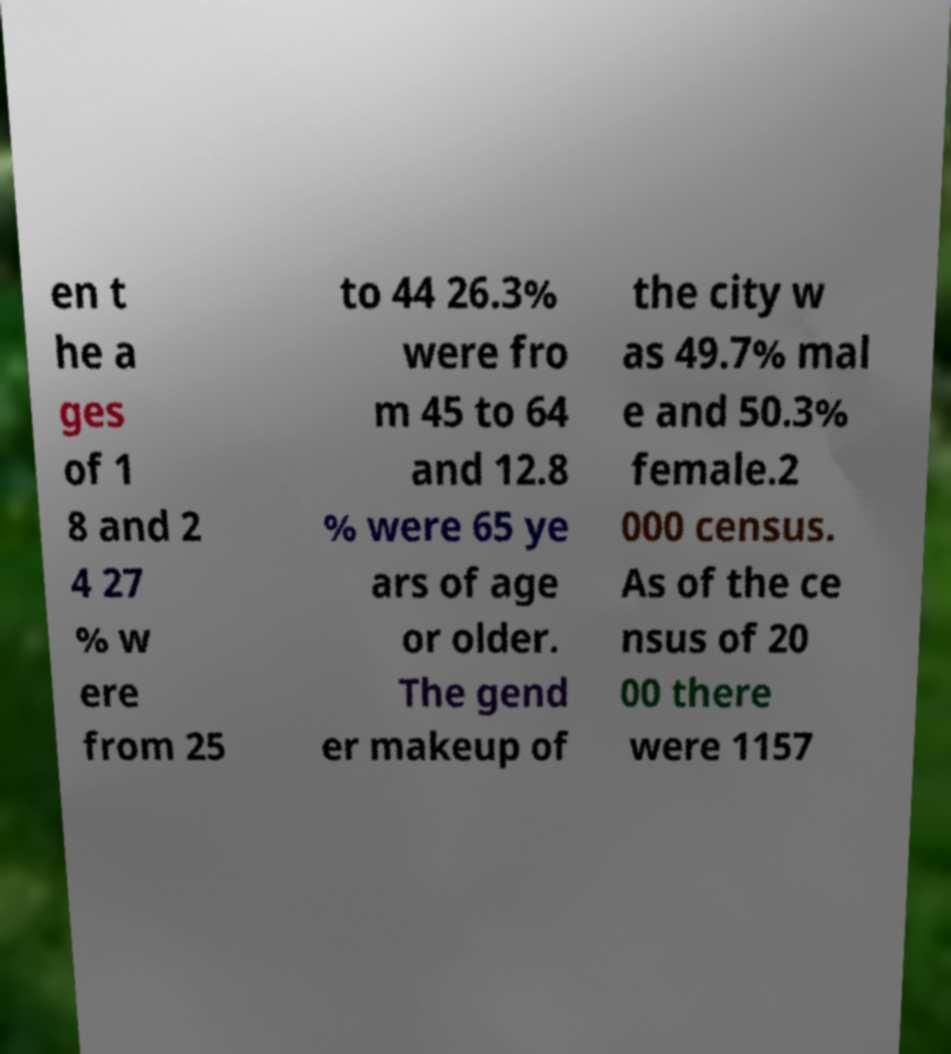Please read and relay the text visible in this image. What does it say? en t he a ges of 1 8 and 2 4 27 % w ere from 25 to 44 26.3% were fro m 45 to 64 and 12.8 % were 65 ye ars of age or older. The gend er makeup of the city w as 49.7% mal e and 50.3% female.2 000 census. As of the ce nsus of 20 00 there were 1157 